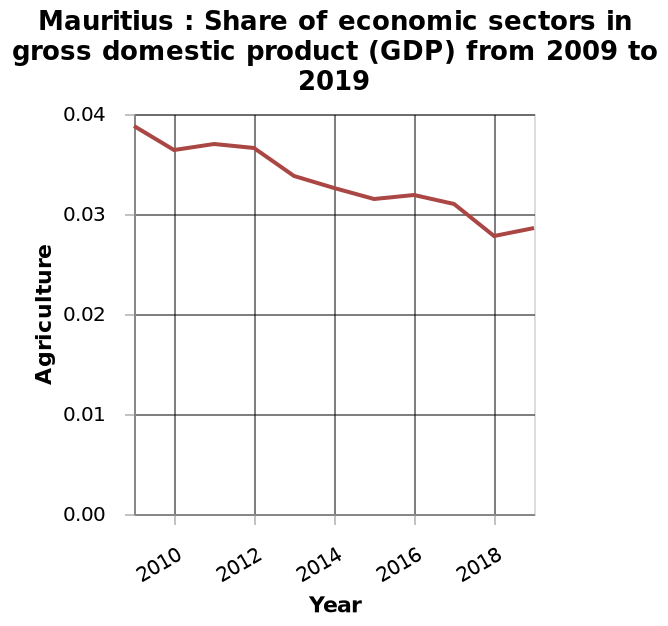<image>
Is the decline in Mauritius' GDP output for agriculture consistent or fluctuating? It is consistent. 